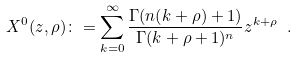Convert formula to latex. <formula><loc_0><loc_0><loc_500><loc_500>X ^ { 0 } ( z , \rho ) \colon = \sum _ { k = 0 } ^ { \infty } \frac { \Gamma ( n ( k + \rho ) + 1 ) } { \Gamma ( k + \rho + 1 ) ^ { n } } z ^ { k + \rho } \ .</formula> 